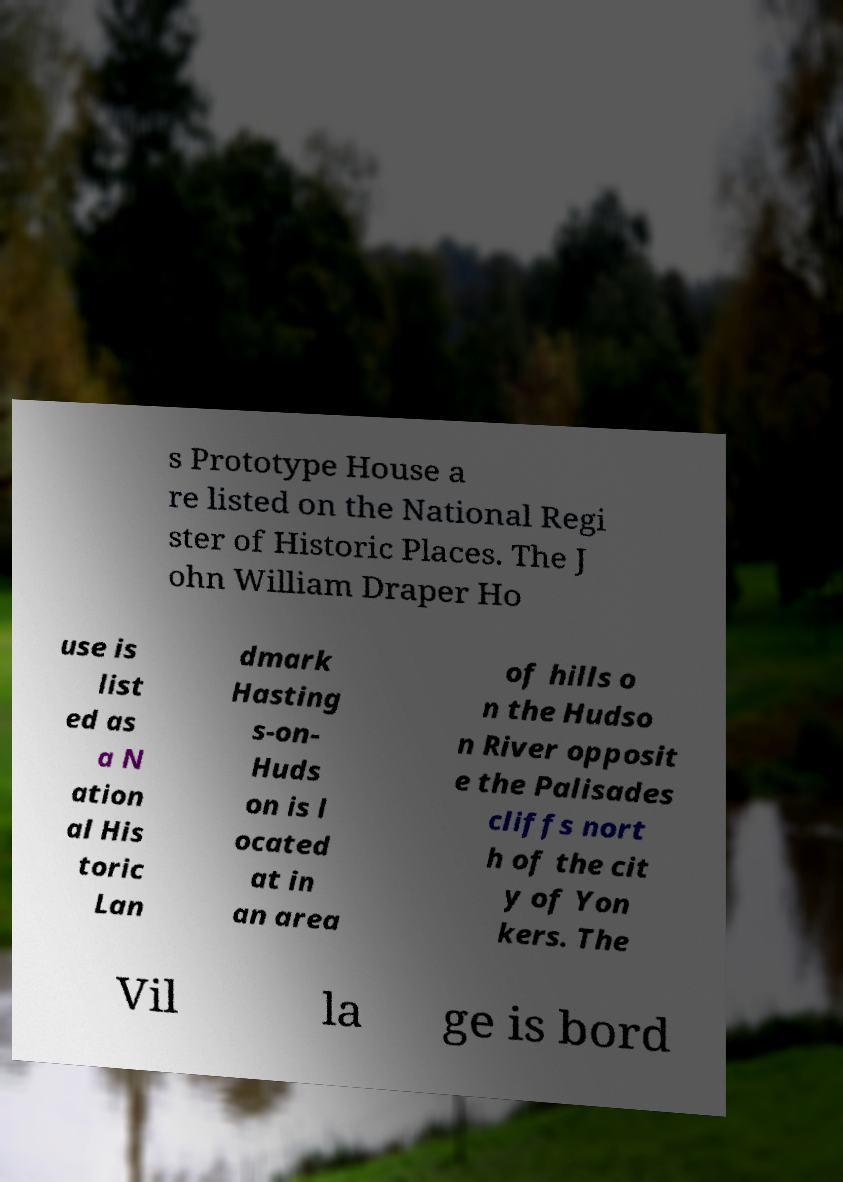For documentation purposes, I need the text within this image transcribed. Could you provide that? s Prototype House a re listed on the National Regi ster of Historic Places. The J ohn William Draper Ho use is list ed as a N ation al His toric Lan dmark Hasting s-on- Huds on is l ocated at in an area of hills o n the Hudso n River opposit e the Palisades cliffs nort h of the cit y of Yon kers. The Vil la ge is bord 